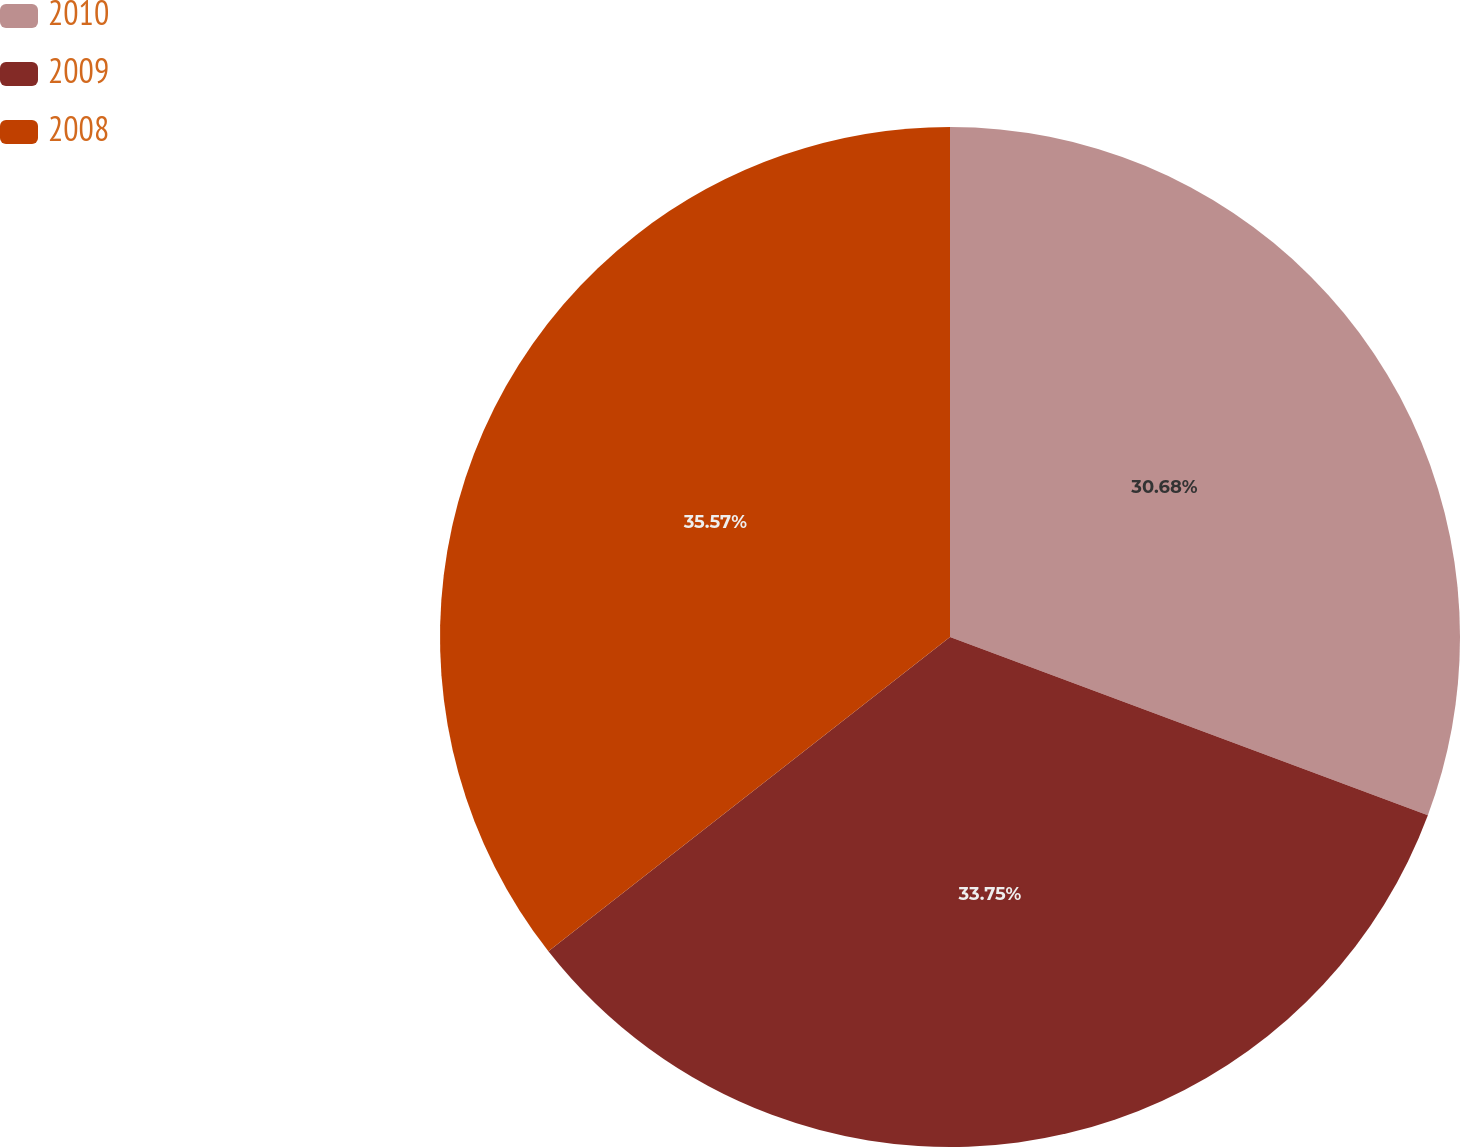Convert chart. <chart><loc_0><loc_0><loc_500><loc_500><pie_chart><fcel>2010<fcel>2009<fcel>2008<nl><fcel>30.68%<fcel>33.75%<fcel>35.57%<nl></chart> 